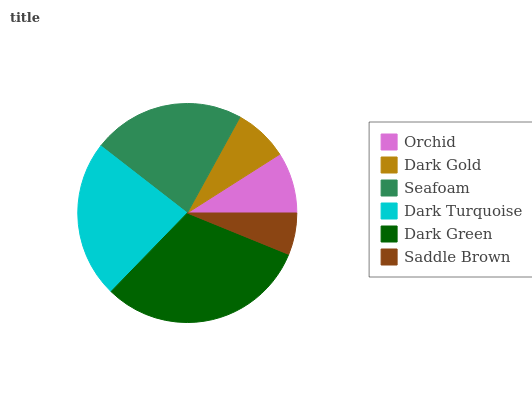Is Saddle Brown the minimum?
Answer yes or no. Yes. Is Dark Green the maximum?
Answer yes or no. Yes. Is Dark Gold the minimum?
Answer yes or no. No. Is Dark Gold the maximum?
Answer yes or no. No. Is Orchid greater than Dark Gold?
Answer yes or no. Yes. Is Dark Gold less than Orchid?
Answer yes or no. Yes. Is Dark Gold greater than Orchid?
Answer yes or no. No. Is Orchid less than Dark Gold?
Answer yes or no. No. Is Seafoam the high median?
Answer yes or no. Yes. Is Orchid the low median?
Answer yes or no. Yes. Is Dark Gold the high median?
Answer yes or no. No. Is Dark Turquoise the low median?
Answer yes or no. No. 